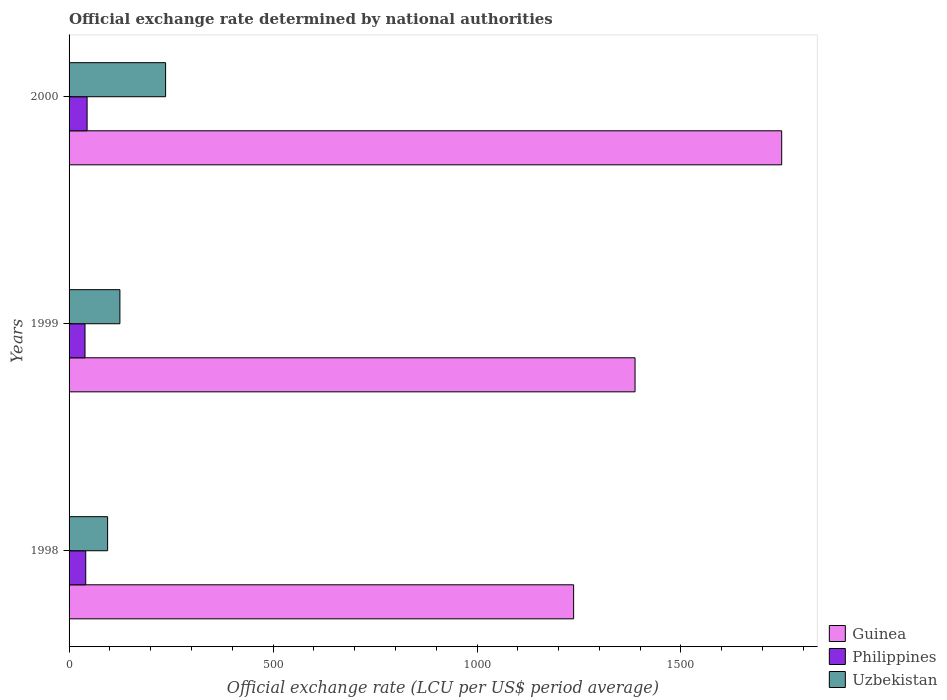How many different coloured bars are there?
Your response must be concise. 3. Are the number of bars on each tick of the Y-axis equal?
Your answer should be compact. Yes. How many bars are there on the 1st tick from the top?
Provide a succinct answer. 3. What is the label of the 3rd group of bars from the top?
Offer a very short reply. 1998. What is the official exchange rate in Uzbekistan in 1999?
Give a very brief answer. 124.62. Across all years, what is the maximum official exchange rate in Guinea?
Your response must be concise. 1746.87. Across all years, what is the minimum official exchange rate in Guinea?
Make the answer very short. 1236.83. In which year was the official exchange rate in Guinea maximum?
Provide a short and direct response. 2000. What is the total official exchange rate in Guinea in the graph?
Your answer should be very brief. 4371.1. What is the difference between the official exchange rate in Guinea in 1998 and that in 2000?
Your response must be concise. -510.04. What is the difference between the official exchange rate in Philippines in 1998 and the official exchange rate in Guinea in 1999?
Ensure brevity in your answer.  -1346.51. What is the average official exchange rate in Philippines per year?
Give a very brief answer. 41.39. In the year 2000, what is the difference between the official exchange rate in Uzbekistan and official exchange rate in Guinea?
Your answer should be very brief. -1510.26. In how many years, is the official exchange rate in Uzbekistan greater than 600 LCU?
Keep it short and to the point. 0. What is the ratio of the official exchange rate in Philippines in 1999 to that in 2000?
Offer a very short reply. 0.88. What is the difference between the highest and the second highest official exchange rate in Uzbekistan?
Your answer should be very brief. 111.98. What is the difference between the highest and the lowest official exchange rate in Guinea?
Offer a terse response. 510.04. In how many years, is the official exchange rate in Guinea greater than the average official exchange rate in Guinea taken over all years?
Your answer should be compact. 1. Is the sum of the official exchange rate in Philippines in 1999 and 2000 greater than the maximum official exchange rate in Uzbekistan across all years?
Your answer should be compact. No. What does the 1st bar from the top in 1999 represents?
Offer a very short reply. Uzbekistan. What does the 2nd bar from the bottom in 1999 represents?
Your response must be concise. Philippines. Does the graph contain any zero values?
Your answer should be very brief. No. Where does the legend appear in the graph?
Keep it short and to the point. Bottom right. How many legend labels are there?
Give a very brief answer. 3. What is the title of the graph?
Your answer should be compact. Official exchange rate determined by national authorities. Does "Thailand" appear as one of the legend labels in the graph?
Your answer should be very brief. No. What is the label or title of the X-axis?
Provide a short and direct response. Official exchange rate (LCU per US$ period average). What is the Official exchange rate (LCU per US$ period average) of Guinea in 1998?
Ensure brevity in your answer.  1236.83. What is the Official exchange rate (LCU per US$ period average) in Philippines in 1998?
Give a very brief answer. 40.89. What is the Official exchange rate (LCU per US$ period average) in Uzbekistan in 1998?
Your response must be concise. 94.49. What is the Official exchange rate (LCU per US$ period average) in Guinea in 1999?
Keep it short and to the point. 1387.4. What is the Official exchange rate (LCU per US$ period average) in Philippines in 1999?
Your answer should be very brief. 39.09. What is the Official exchange rate (LCU per US$ period average) of Uzbekistan in 1999?
Your answer should be compact. 124.62. What is the Official exchange rate (LCU per US$ period average) in Guinea in 2000?
Ensure brevity in your answer.  1746.87. What is the Official exchange rate (LCU per US$ period average) of Philippines in 2000?
Provide a short and direct response. 44.19. What is the Official exchange rate (LCU per US$ period average) of Uzbekistan in 2000?
Your answer should be compact. 236.61. Across all years, what is the maximum Official exchange rate (LCU per US$ period average) in Guinea?
Provide a short and direct response. 1746.87. Across all years, what is the maximum Official exchange rate (LCU per US$ period average) of Philippines?
Ensure brevity in your answer.  44.19. Across all years, what is the maximum Official exchange rate (LCU per US$ period average) of Uzbekistan?
Your answer should be very brief. 236.61. Across all years, what is the minimum Official exchange rate (LCU per US$ period average) of Guinea?
Offer a terse response. 1236.83. Across all years, what is the minimum Official exchange rate (LCU per US$ period average) in Philippines?
Offer a very short reply. 39.09. Across all years, what is the minimum Official exchange rate (LCU per US$ period average) of Uzbekistan?
Ensure brevity in your answer.  94.49. What is the total Official exchange rate (LCU per US$ period average) in Guinea in the graph?
Your answer should be very brief. 4371.1. What is the total Official exchange rate (LCU per US$ period average) of Philippines in the graph?
Give a very brief answer. 124.17. What is the total Official exchange rate (LCU per US$ period average) of Uzbekistan in the graph?
Provide a succinct answer. 455.73. What is the difference between the Official exchange rate (LCU per US$ period average) in Guinea in 1998 and that in 1999?
Give a very brief answer. -150.57. What is the difference between the Official exchange rate (LCU per US$ period average) in Philippines in 1998 and that in 1999?
Provide a short and direct response. 1.8. What is the difference between the Official exchange rate (LCU per US$ period average) of Uzbekistan in 1998 and that in 1999?
Keep it short and to the point. -30.13. What is the difference between the Official exchange rate (LCU per US$ period average) in Guinea in 1998 and that in 2000?
Your response must be concise. -510.04. What is the difference between the Official exchange rate (LCU per US$ period average) of Philippines in 1998 and that in 2000?
Keep it short and to the point. -3.3. What is the difference between the Official exchange rate (LCU per US$ period average) in Uzbekistan in 1998 and that in 2000?
Ensure brevity in your answer.  -142.12. What is the difference between the Official exchange rate (LCU per US$ period average) of Guinea in 1999 and that in 2000?
Your answer should be very brief. -359.47. What is the difference between the Official exchange rate (LCU per US$ period average) in Philippines in 1999 and that in 2000?
Give a very brief answer. -5.1. What is the difference between the Official exchange rate (LCU per US$ period average) of Uzbekistan in 1999 and that in 2000?
Make the answer very short. -111.98. What is the difference between the Official exchange rate (LCU per US$ period average) of Guinea in 1998 and the Official exchange rate (LCU per US$ period average) of Philippines in 1999?
Give a very brief answer. 1197.74. What is the difference between the Official exchange rate (LCU per US$ period average) of Guinea in 1998 and the Official exchange rate (LCU per US$ period average) of Uzbekistan in 1999?
Ensure brevity in your answer.  1112.21. What is the difference between the Official exchange rate (LCU per US$ period average) in Philippines in 1998 and the Official exchange rate (LCU per US$ period average) in Uzbekistan in 1999?
Keep it short and to the point. -83.73. What is the difference between the Official exchange rate (LCU per US$ period average) in Guinea in 1998 and the Official exchange rate (LCU per US$ period average) in Philippines in 2000?
Provide a short and direct response. 1192.64. What is the difference between the Official exchange rate (LCU per US$ period average) of Guinea in 1998 and the Official exchange rate (LCU per US$ period average) of Uzbekistan in 2000?
Ensure brevity in your answer.  1000.22. What is the difference between the Official exchange rate (LCU per US$ period average) in Philippines in 1998 and the Official exchange rate (LCU per US$ period average) in Uzbekistan in 2000?
Ensure brevity in your answer.  -195.72. What is the difference between the Official exchange rate (LCU per US$ period average) of Guinea in 1999 and the Official exchange rate (LCU per US$ period average) of Philippines in 2000?
Make the answer very short. 1343.21. What is the difference between the Official exchange rate (LCU per US$ period average) of Guinea in 1999 and the Official exchange rate (LCU per US$ period average) of Uzbekistan in 2000?
Offer a terse response. 1150.79. What is the difference between the Official exchange rate (LCU per US$ period average) in Philippines in 1999 and the Official exchange rate (LCU per US$ period average) in Uzbekistan in 2000?
Give a very brief answer. -197.52. What is the average Official exchange rate (LCU per US$ period average) of Guinea per year?
Your answer should be very brief. 1457.03. What is the average Official exchange rate (LCU per US$ period average) in Philippines per year?
Your response must be concise. 41.39. What is the average Official exchange rate (LCU per US$ period average) in Uzbekistan per year?
Your response must be concise. 151.91. In the year 1998, what is the difference between the Official exchange rate (LCU per US$ period average) of Guinea and Official exchange rate (LCU per US$ period average) of Philippines?
Make the answer very short. 1195.94. In the year 1998, what is the difference between the Official exchange rate (LCU per US$ period average) in Guinea and Official exchange rate (LCU per US$ period average) in Uzbekistan?
Your answer should be very brief. 1142.34. In the year 1998, what is the difference between the Official exchange rate (LCU per US$ period average) of Philippines and Official exchange rate (LCU per US$ period average) of Uzbekistan?
Your answer should be compact. -53.6. In the year 1999, what is the difference between the Official exchange rate (LCU per US$ period average) of Guinea and Official exchange rate (LCU per US$ period average) of Philippines?
Your answer should be very brief. 1348.31. In the year 1999, what is the difference between the Official exchange rate (LCU per US$ period average) in Guinea and Official exchange rate (LCU per US$ period average) in Uzbekistan?
Keep it short and to the point. 1262.78. In the year 1999, what is the difference between the Official exchange rate (LCU per US$ period average) in Philippines and Official exchange rate (LCU per US$ period average) in Uzbekistan?
Provide a succinct answer. -85.54. In the year 2000, what is the difference between the Official exchange rate (LCU per US$ period average) of Guinea and Official exchange rate (LCU per US$ period average) of Philippines?
Your answer should be compact. 1702.68. In the year 2000, what is the difference between the Official exchange rate (LCU per US$ period average) of Guinea and Official exchange rate (LCU per US$ period average) of Uzbekistan?
Provide a short and direct response. 1510.26. In the year 2000, what is the difference between the Official exchange rate (LCU per US$ period average) in Philippines and Official exchange rate (LCU per US$ period average) in Uzbekistan?
Provide a short and direct response. -192.42. What is the ratio of the Official exchange rate (LCU per US$ period average) in Guinea in 1998 to that in 1999?
Ensure brevity in your answer.  0.89. What is the ratio of the Official exchange rate (LCU per US$ period average) in Philippines in 1998 to that in 1999?
Keep it short and to the point. 1.05. What is the ratio of the Official exchange rate (LCU per US$ period average) of Uzbekistan in 1998 to that in 1999?
Provide a short and direct response. 0.76. What is the ratio of the Official exchange rate (LCU per US$ period average) of Guinea in 1998 to that in 2000?
Make the answer very short. 0.71. What is the ratio of the Official exchange rate (LCU per US$ period average) in Philippines in 1998 to that in 2000?
Your response must be concise. 0.93. What is the ratio of the Official exchange rate (LCU per US$ period average) in Uzbekistan in 1998 to that in 2000?
Your answer should be compact. 0.4. What is the ratio of the Official exchange rate (LCU per US$ period average) of Guinea in 1999 to that in 2000?
Ensure brevity in your answer.  0.79. What is the ratio of the Official exchange rate (LCU per US$ period average) in Philippines in 1999 to that in 2000?
Offer a terse response. 0.88. What is the ratio of the Official exchange rate (LCU per US$ period average) in Uzbekistan in 1999 to that in 2000?
Make the answer very short. 0.53. What is the difference between the highest and the second highest Official exchange rate (LCU per US$ period average) of Guinea?
Keep it short and to the point. 359.47. What is the difference between the highest and the second highest Official exchange rate (LCU per US$ period average) in Philippines?
Your response must be concise. 3.3. What is the difference between the highest and the second highest Official exchange rate (LCU per US$ period average) of Uzbekistan?
Ensure brevity in your answer.  111.98. What is the difference between the highest and the lowest Official exchange rate (LCU per US$ period average) in Guinea?
Offer a very short reply. 510.04. What is the difference between the highest and the lowest Official exchange rate (LCU per US$ period average) in Philippines?
Your answer should be very brief. 5.1. What is the difference between the highest and the lowest Official exchange rate (LCU per US$ period average) in Uzbekistan?
Offer a terse response. 142.12. 